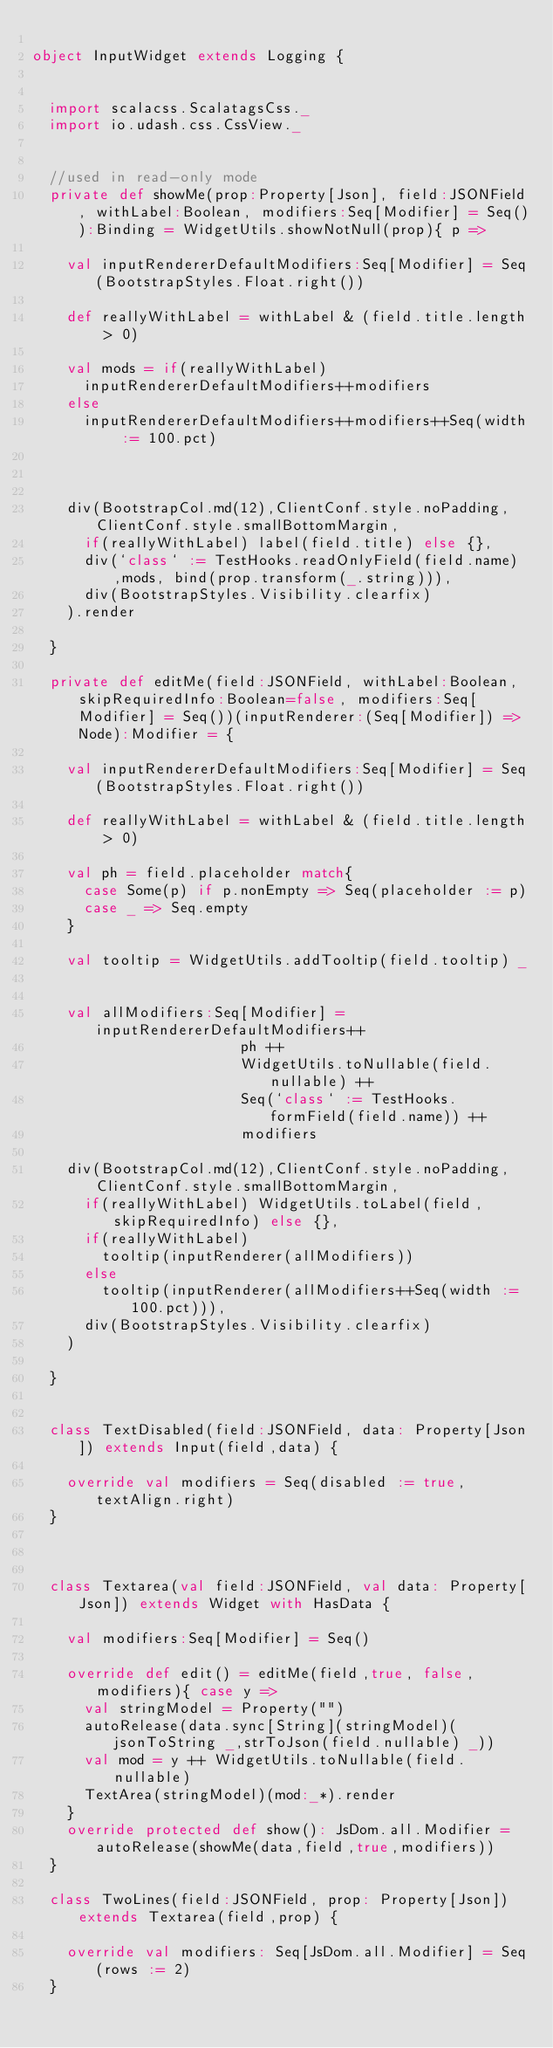<code> <loc_0><loc_0><loc_500><loc_500><_Scala_>
object InputWidget extends Logging {


  import scalacss.ScalatagsCss._
  import io.udash.css.CssView._


  //used in read-only mode
  private def showMe(prop:Property[Json], field:JSONField, withLabel:Boolean, modifiers:Seq[Modifier] = Seq()):Binding = WidgetUtils.showNotNull(prop){ p =>

    val inputRendererDefaultModifiers:Seq[Modifier] = Seq(BootstrapStyles.Float.right())

    def reallyWithLabel = withLabel & (field.title.length > 0)

    val mods = if(reallyWithLabel)
      inputRendererDefaultModifiers++modifiers
    else
      inputRendererDefaultModifiers++modifiers++Seq(width := 100.pct)



    div(BootstrapCol.md(12),ClientConf.style.noPadding,ClientConf.style.smallBottomMargin,
      if(reallyWithLabel) label(field.title) else {},
      div(`class` := TestHooks.readOnlyField(field.name) ,mods, bind(prop.transform(_.string))),
      div(BootstrapStyles.Visibility.clearfix)
    ).render

  }

  private def editMe(field:JSONField, withLabel:Boolean, skipRequiredInfo:Boolean=false, modifiers:Seq[Modifier] = Seq())(inputRenderer:(Seq[Modifier]) => Node):Modifier = {

    val inputRendererDefaultModifiers:Seq[Modifier] = Seq(BootstrapStyles.Float.right())

    def reallyWithLabel = withLabel & (field.title.length > 0)

    val ph = field.placeholder match{
      case Some(p) if p.nonEmpty => Seq(placeholder := p)
      case _ => Seq.empty
    }

    val tooltip = WidgetUtils.addTooltip(field.tooltip) _


    val allModifiers:Seq[Modifier] =  inputRendererDefaultModifiers++
                        ph ++
                        WidgetUtils.toNullable(field.nullable) ++
                        Seq(`class` := TestHooks.formField(field.name)) ++
                        modifiers

    div(BootstrapCol.md(12),ClientConf.style.noPadding,ClientConf.style.smallBottomMargin,
      if(reallyWithLabel) WidgetUtils.toLabel(field, skipRequiredInfo) else {},
      if(reallyWithLabel)
        tooltip(inputRenderer(allModifiers))
      else
        tooltip(inputRenderer(allModifiers++Seq(width := 100.pct))),
      div(BootstrapStyles.Visibility.clearfix)
    )

  }


  class TextDisabled(field:JSONField, data: Property[Json]) extends Input(field,data) {

    override val modifiers = Seq(disabled := true, textAlign.right)
  }



  class Textarea(val field:JSONField, val data: Property[Json]) extends Widget with HasData {

    val modifiers:Seq[Modifier] = Seq()

    override def edit() = editMe(field,true, false, modifiers){ case y =>
      val stringModel = Property("")
      autoRelease(data.sync[String](stringModel)(jsonToString _,strToJson(field.nullable) _))
      val mod = y ++ WidgetUtils.toNullable(field.nullable)
      TextArea(stringModel)(mod:_*).render
    }
    override protected def show(): JsDom.all.Modifier = autoRelease(showMe(data,field,true,modifiers))
  }

  class TwoLines(field:JSONField, prop: Property[Json]) extends Textarea(field,prop) {

    override val modifiers: Seq[JsDom.all.Modifier] = Seq(rows := 2)
  }

</code> 